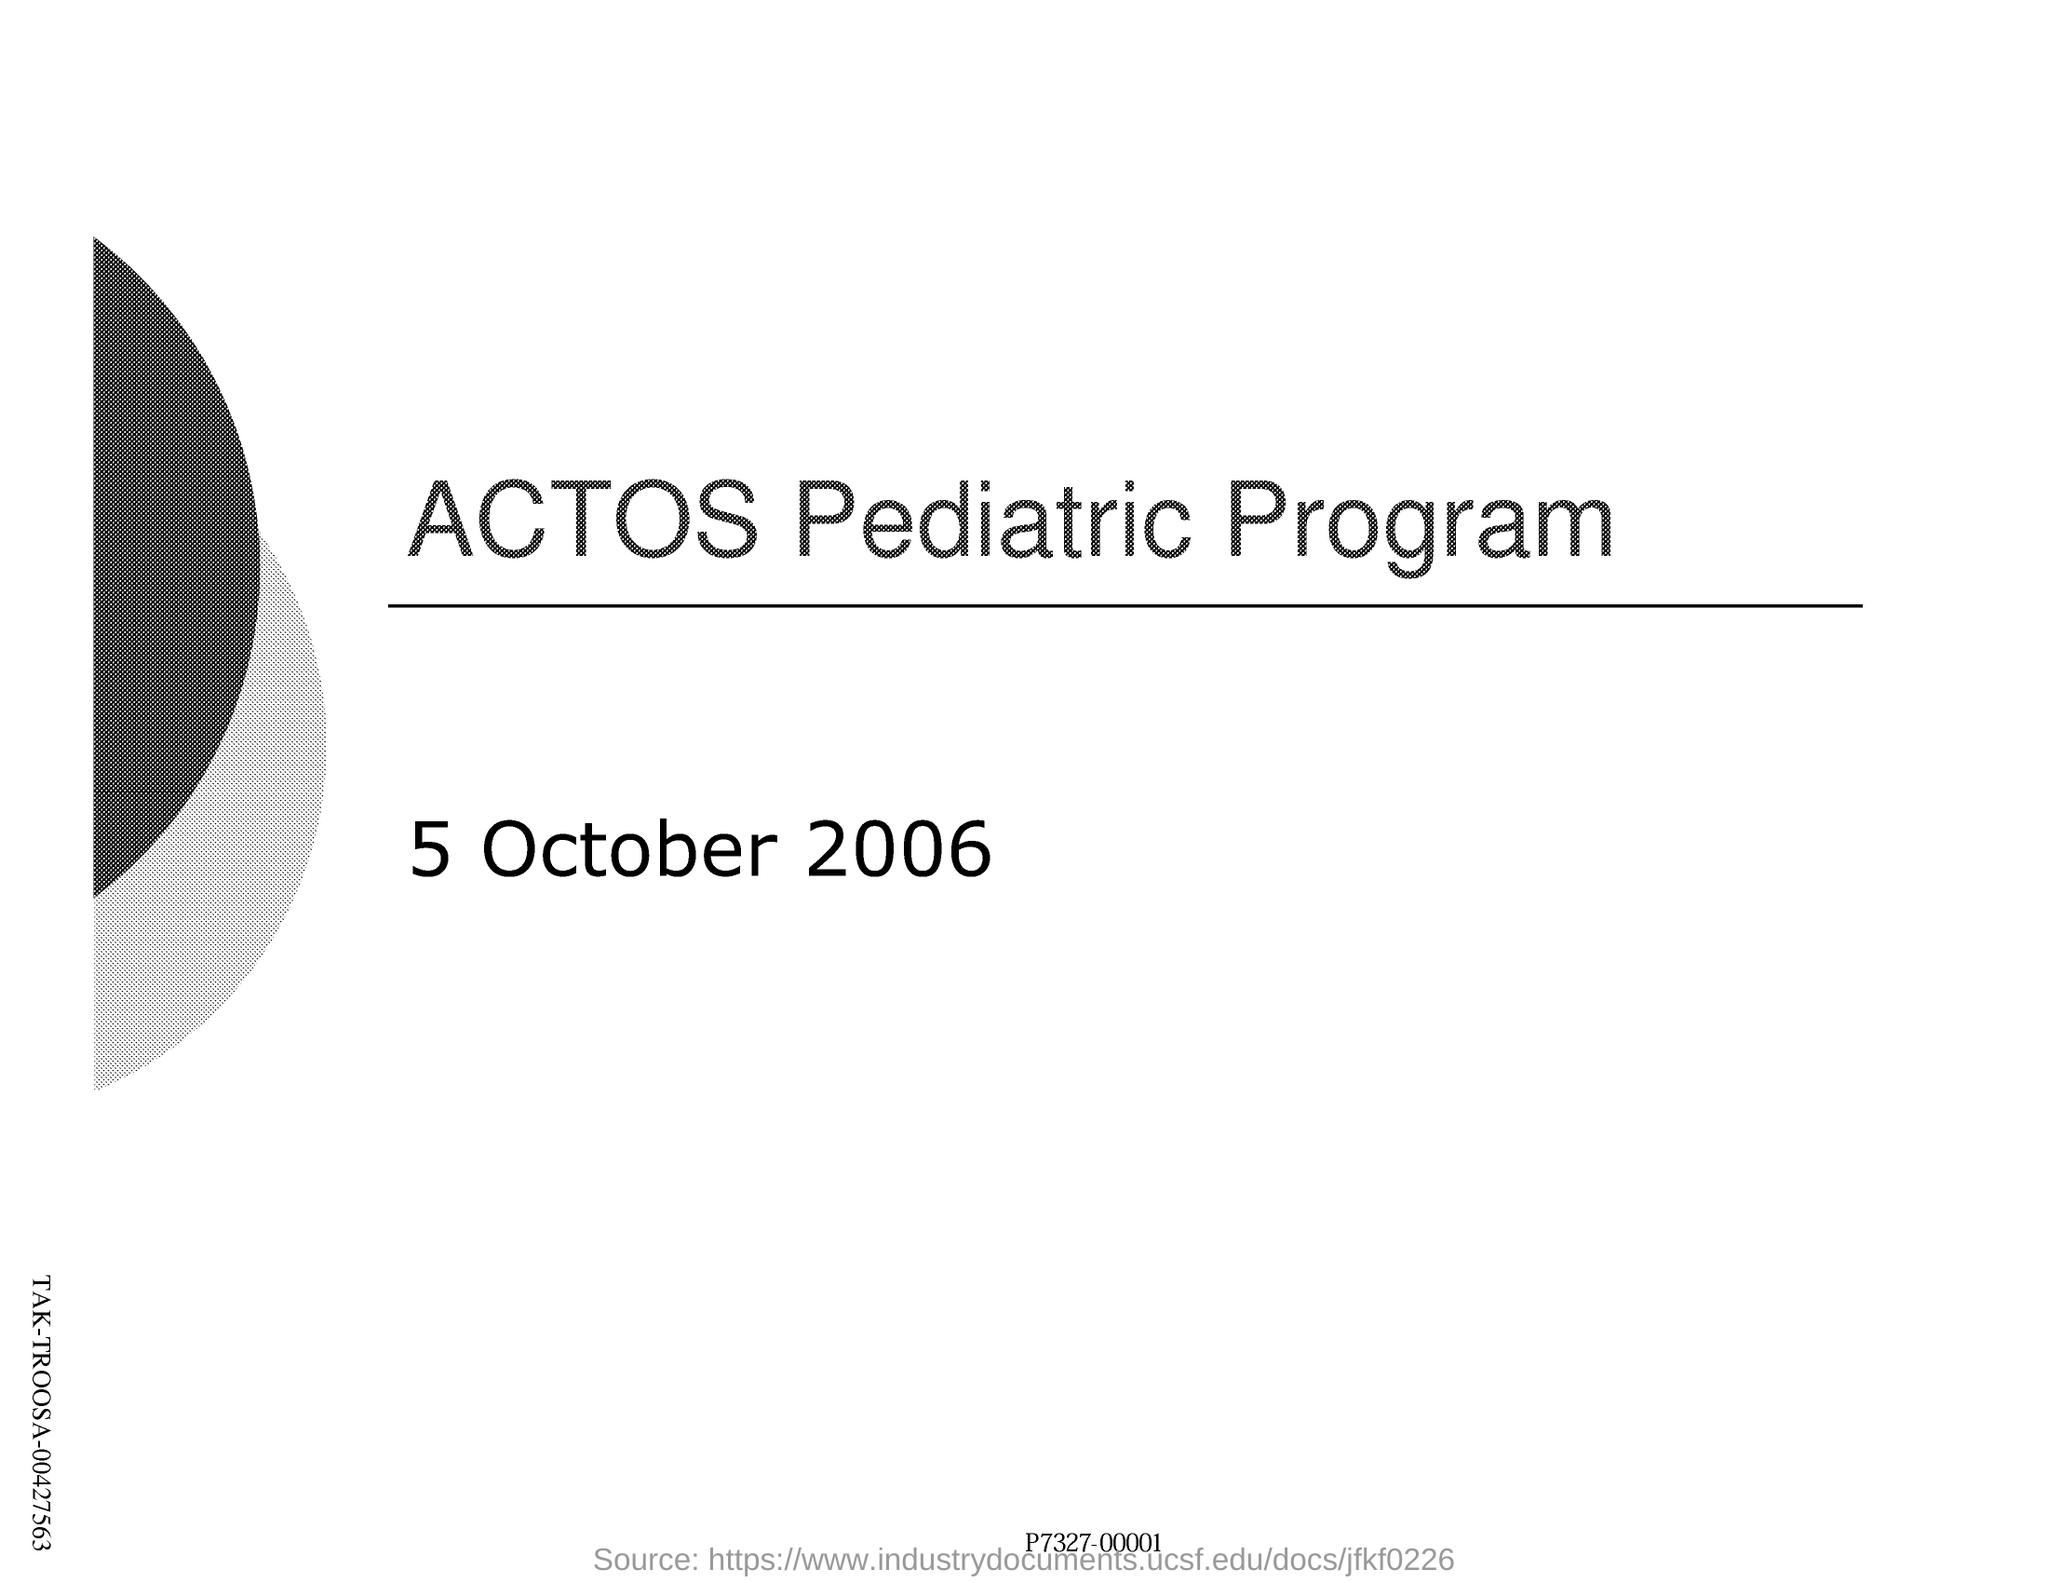Give some essential details in this illustration. The name of the pediatric program is ACTOS. The date mentioned on this page is 5 October 2006. 